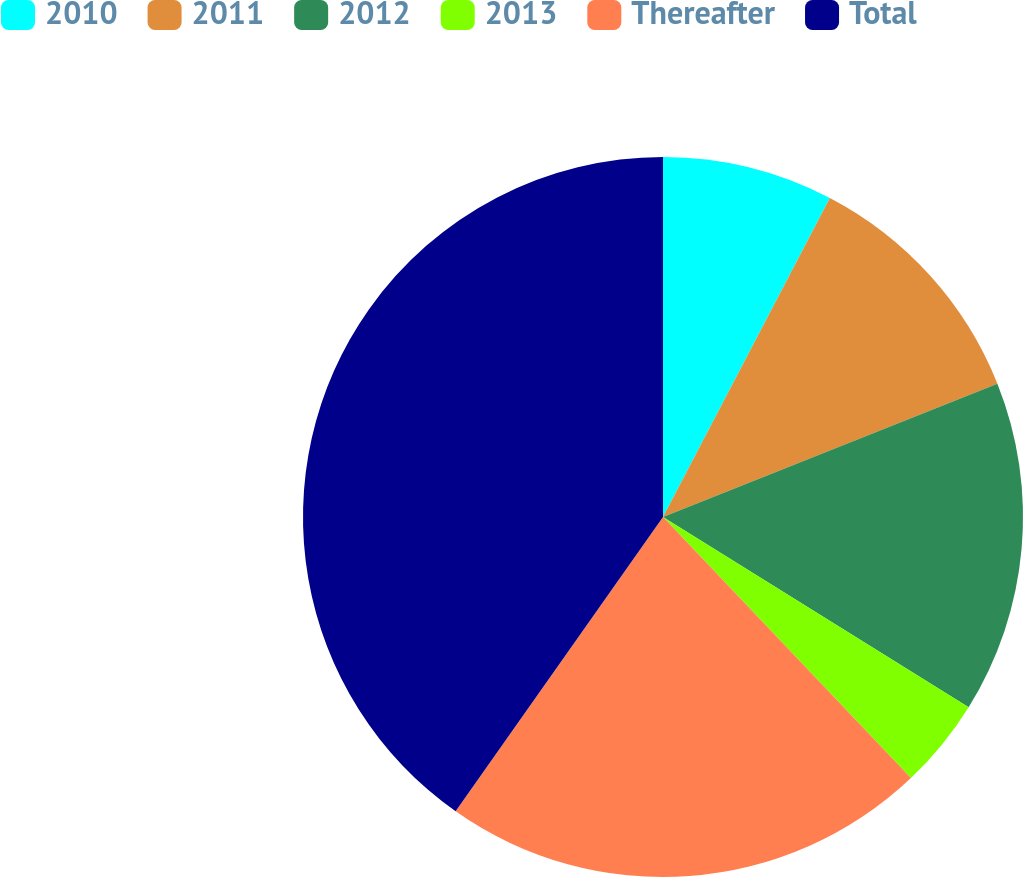Convert chart to OTSL. <chart><loc_0><loc_0><loc_500><loc_500><pie_chart><fcel>2010<fcel>2011<fcel>2012<fcel>2013<fcel>Thereafter<fcel>Total<nl><fcel>7.67%<fcel>11.29%<fcel>14.9%<fcel>4.05%<fcel>21.86%<fcel>40.23%<nl></chart> 